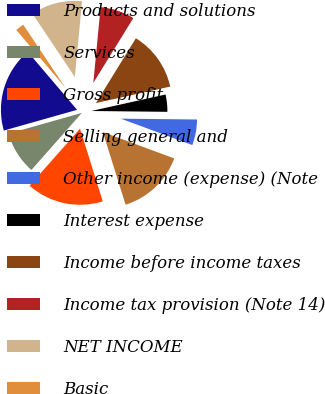Convert chart. <chart><loc_0><loc_0><loc_500><loc_500><pie_chart><fcel>Products and solutions<fcel>Services<fcel>Gross profit<fcel>Selling general and<fcel>Other income (expense) (Note<fcel>Interest expense<fcel>Income before income taxes<fcel>Income tax provision (Note 14)<fcel>NET INCOME<fcel>Basic<nl><fcel>18.17%<fcel>9.09%<fcel>16.35%<fcel>14.54%<fcel>5.46%<fcel>3.65%<fcel>12.72%<fcel>7.28%<fcel>10.91%<fcel>1.83%<nl></chart> 